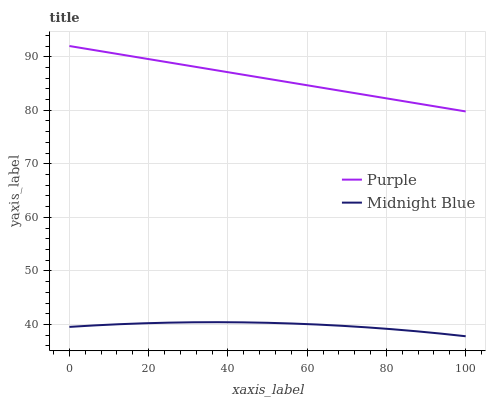Does Midnight Blue have the minimum area under the curve?
Answer yes or no. Yes. Does Purple have the maximum area under the curve?
Answer yes or no. Yes. Does Midnight Blue have the maximum area under the curve?
Answer yes or no. No. Is Purple the smoothest?
Answer yes or no. Yes. Is Midnight Blue the roughest?
Answer yes or no. Yes. Is Midnight Blue the smoothest?
Answer yes or no. No. Does Midnight Blue have the highest value?
Answer yes or no. No. Is Midnight Blue less than Purple?
Answer yes or no. Yes. Is Purple greater than Midnight Blue?
Answer yes or no. Yes. Does Midnight Blue intersect Purple?
Answer yes or no. No. 